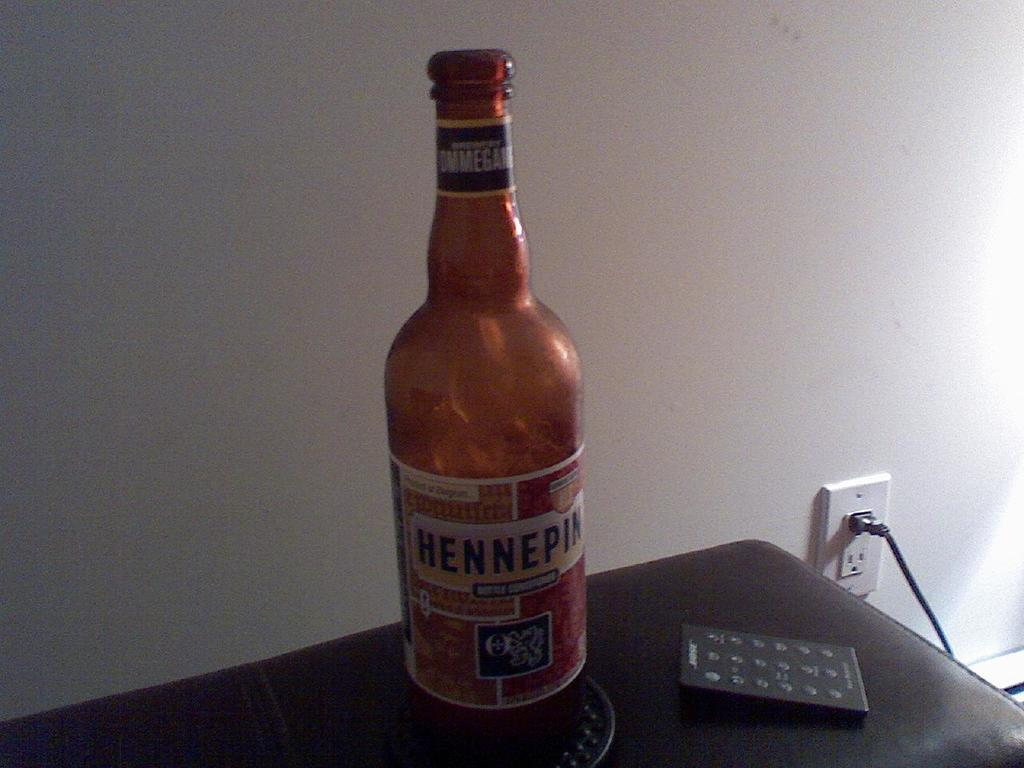What objects are on the table in the image? There is a bottle and a remote on the table in the image. What color is the table in the image? The table is black in color. What can be seen behind the table in the image? There is a wall visible in the image. What type of income can be seen in the image? There is no reference to income in the image; it features a bottle, a remote, and a black table. How many mittens are visible in the image? There are no mittens present in the image. 